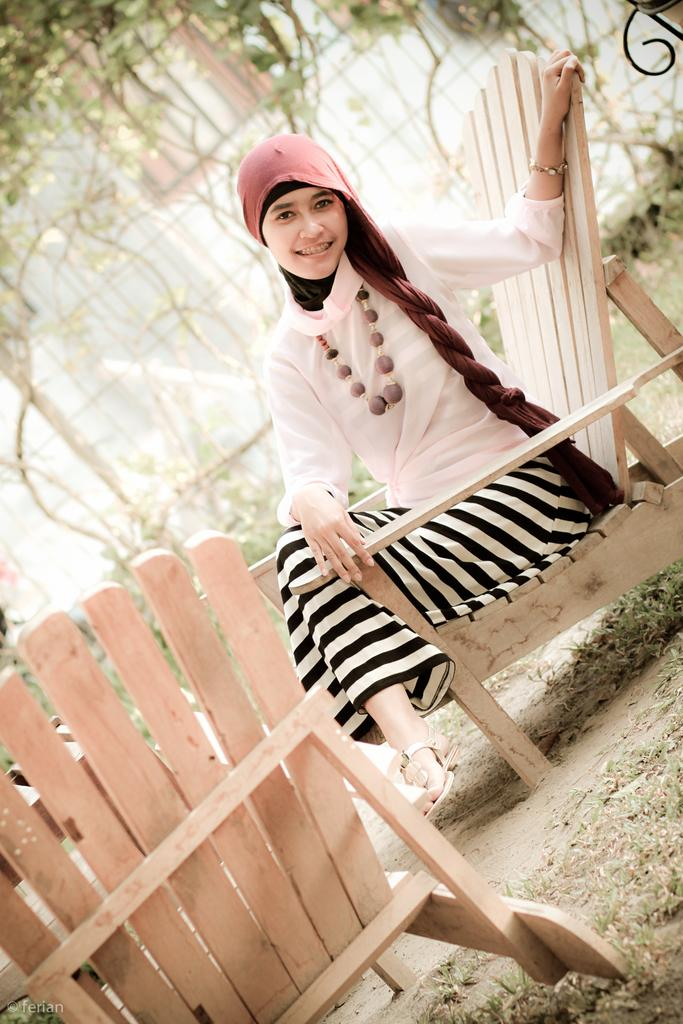What is on the ground in the image? There is a chair on the ground in the image. Who is sitting on the chair? A woman is sitting on the chair. What can be seen in the background of the image? There are plants and a fence in the background of the image. Are there any other objects visible in the background? Yes, there are other objects visible in the background of the image. Can you see the fang of the snake in the image? There is no snake or fang present in the image. How many chains are visible in the image? There are no chains visible in the image. 